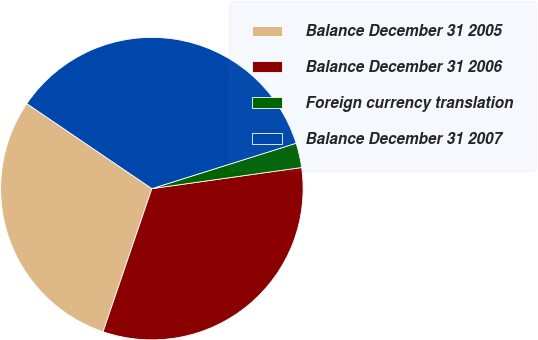<chart> <loc_0><loc_0><loc_500><loc_500><pie_chart><fcel>Balance December 31 2005<fcel>Balance December 31 2006<fcel>Foreign currency translation<fcel>Balance December 31 2007<nl><fcel>29.27%<fcel>32.46%<fcel>2.62%<fcel>35.65%<nl></chart> 